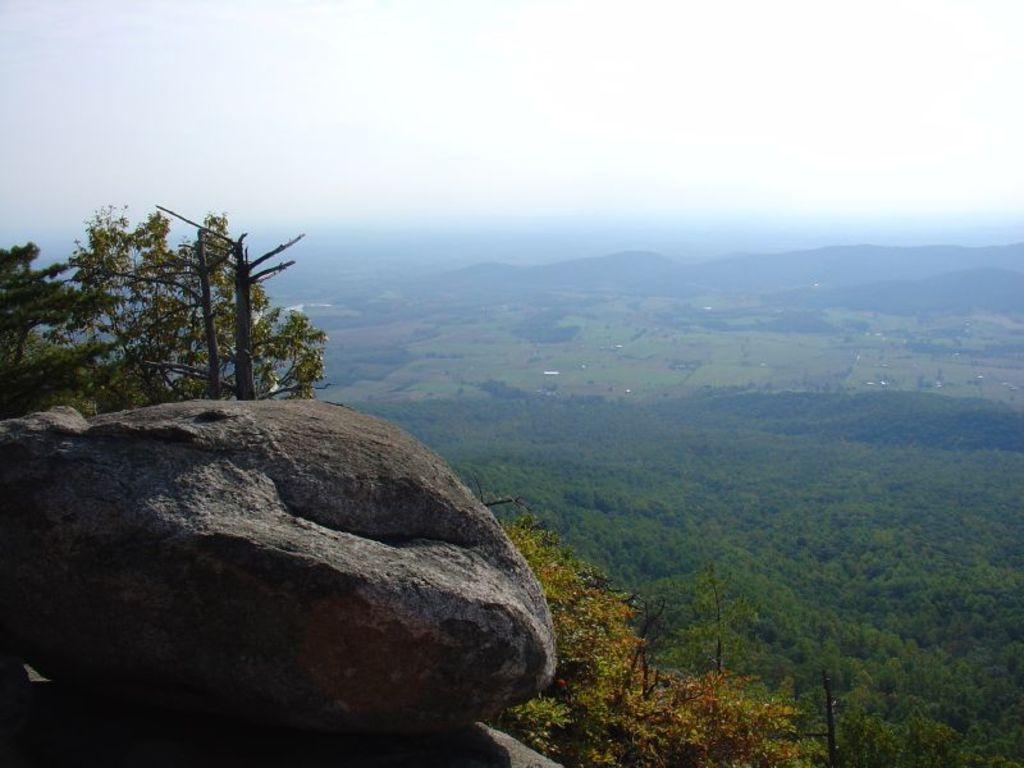Can you describe this image briefly? In the image there is a hill on the left side with trees behind it, in the back the land is covered with plants and trees all over the place and above its sky. 